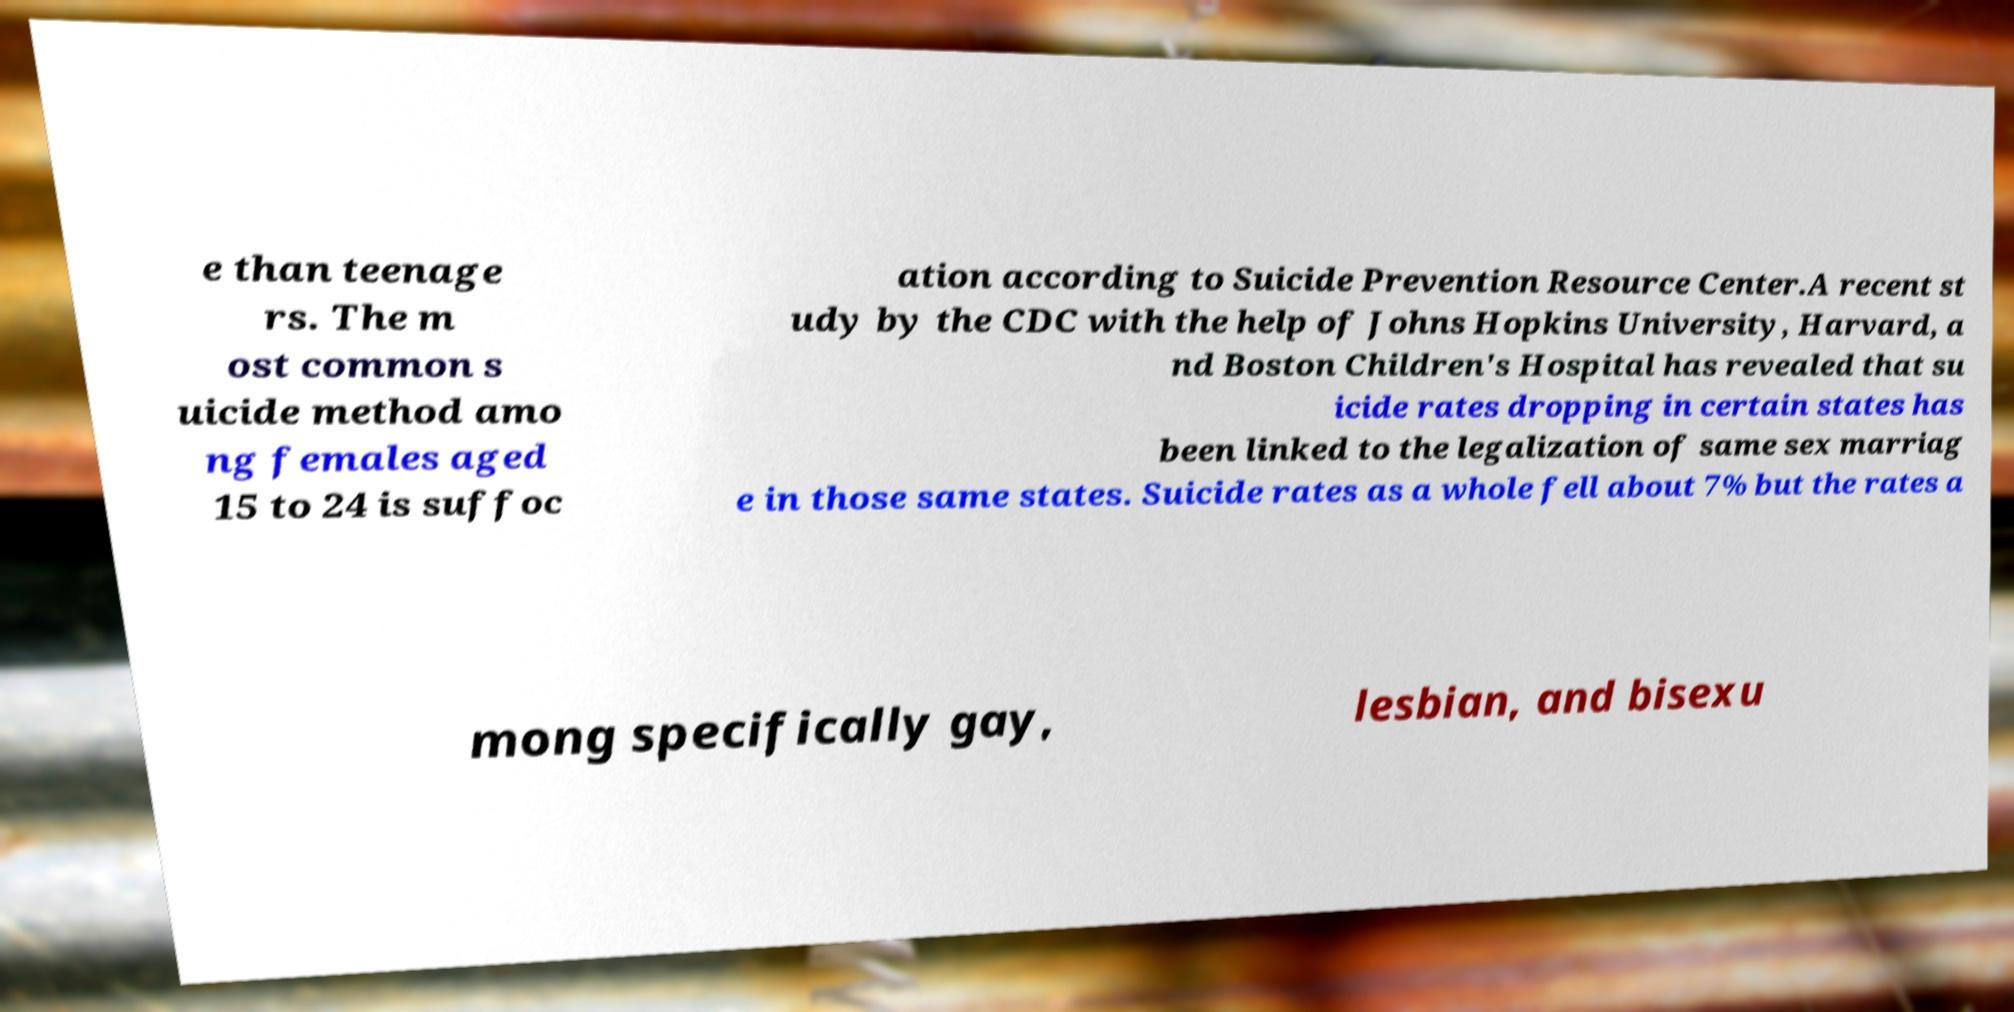Please identify and transcribe the text found in this image. e than teenage rs. The m ost common s uicide method amo ng females aged 15 to 24 is suffoc ation according to Suicide Prevention Resource Center.A recent st udy by the CDC with the help of Johns Hopkins University, Harvard, a nd Boston Children's Hospital has revealed that su icide rates dropping in certain states has been linked to the legalization of same sex marriag e in those same states. Suicide rates as a whole fell about 7% but the rates a mong specifically gay, lesbian, and bisexu 